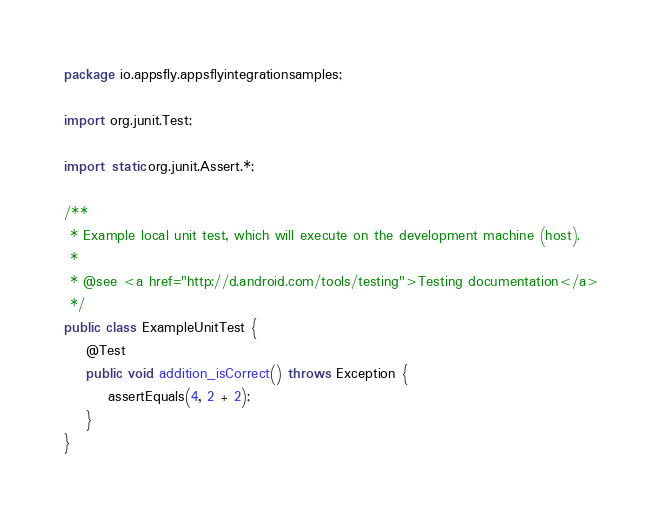Convert code to text. <code><loc_0><loc_0><loc_500><loc_500><_Java_>package io.appsfly.appsflyintegrationsamples;

import org.junit.Test;

import static org.junit.Assert.*;

/**
 * Example local unit test, which will execute on the development machine (host).
 *
 * @see <a href="http://d.android.com/tools/testing">Testing documentation</a>
 */
public class ExampleUnitTest {
    @Test
    public void addition_isCorrect() throws Exception {
        assertEquals(4, 2 + 2);
    }
}</code> 